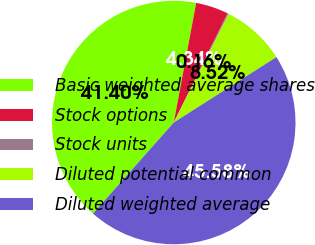<chart> <loc_0><loc_0><loc_500><loc_500><pie_chart><fcel>Basic weighted average shares<fcel>Stock options<fcel>Stock units<fcel>Diluted potential common<fcel>Diluted weighted average<nl><fcel>41.39%<fcel>4.34%<fcel>0.16%<fcel>8.52%<fcel>45.57%<nl></chart> 